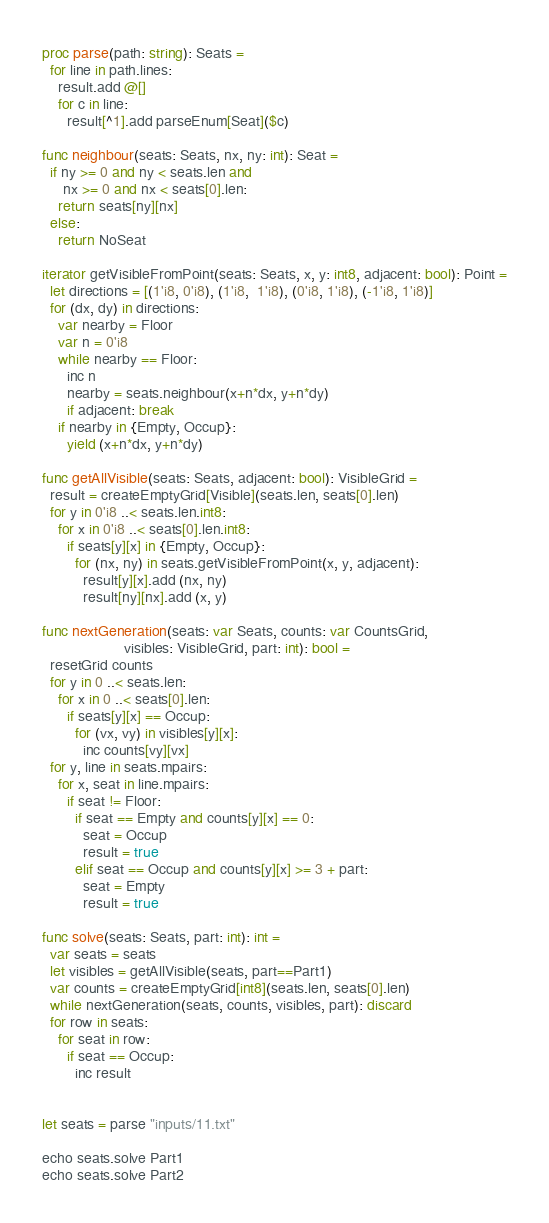Convert code to text. <code><loc_0><loc_0><loc_500><loc_500><_Nim_>proc parse(path: string): Seats =
  for line in path.lines:
    result.add @[]
    for c in line:
      result[^1].add parseEnum[Seat]($c)

func neighbour(seats: Seats, nx, ny: int): Seat =
  if ny >= 0 and ny < seats.len and
     nx >= 0 and nx < seats[0].len:
    return seats[ny][nx]
  else:
    return NoSeat

iterator getVisibleFromPoint(seats: Seats, x, y: int8, adjacent: bool): Point =
  let directions = [(1'i8, 0'i8), (1'i8,  1'i8), (0'i8, 1'i8), (-1'i8, 1'i8)]
  for (dx, dy) in directions:
    var nearby = Floor
    var n = 0'i8
    while nearby == Floor:
      inc n
      nearby = seats.neighbour(x+n*dx, y+n*dy)
      if adjacent: break
    if nearby in {Empty, Occup}:
      yield (x+n*dx, y+n*dy)

func getAllVisible(seats: Seats, adjacent: bool): VisibleGrid =
  result = createEmptyGrid[Visible](seats.len, seats[0].len)
  for y in 0'i8 ..< seats.len.int8:
    for x in 0'i8 ..< seats[0].len.int8:
      if seats[y][x] in {Empty, Occup}:
        for (nx, ny) in seats.getVisibleFromPoint(x, y, adjacent):
          result[y][x].add (nx, ny)
          result[ny][nx].add (x, y)

func nextGeneration(seats: var Seats, counts: var CountsGrid,
                    visibles: VisibleGrid, part: int): bool =
  resetGrid counts
  for y in 0 ..< seats.len:
    for x in 0 ..< seats[0].len:
      if seats[y][x] == Occup:
        for (vx, vy) in visibles[y][x]:
          inc counts[vy][vx]
  for y, line in seats.mpairs:
    for x, seat in line.mpairs:
      if seat != Floor:
        if seat == Empty and counts[y][x] == 0:
          seat = Occup
          result = true
        elif seat == Occup and counts[y][x] >= 3 + part:
          seat = Empty
          result = true

func solve(seats: Seats, part: int): int =
  var seats = seats
  let visibles = getAllVisible(seats, part==Part1)
  var counts = createEmptyGrid[int8](seats.len, seats[0].len)
  while nextGeneration(seats, counts, visibles, part): discard
  for row in seats:
    for seat in row:
      if seat == Occup:
        inc result


let seats = parse "inputs/11.txt"

echo seats.solve Part1
echo seats.solve Part2
</code> 